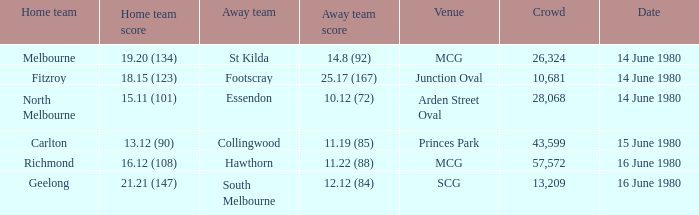On what date the footscray's away game? 14 June 1980. 